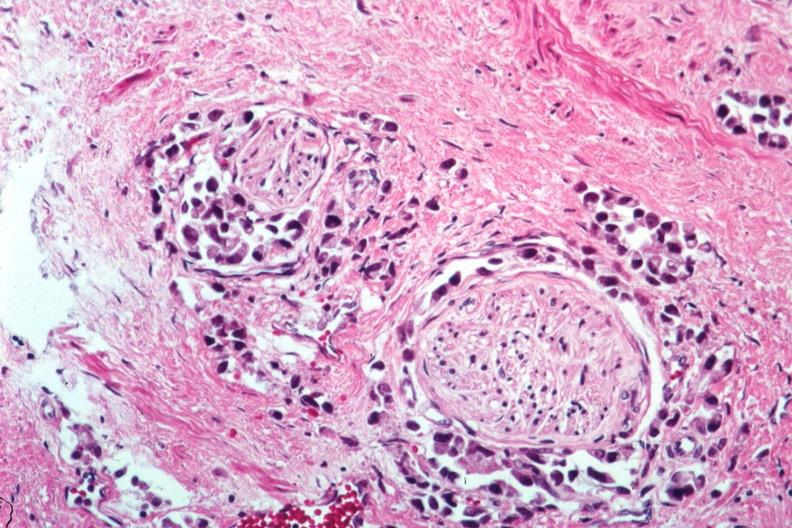what does this image show?
Answer the question using a single word or phrase. Perineural tumor invasion 